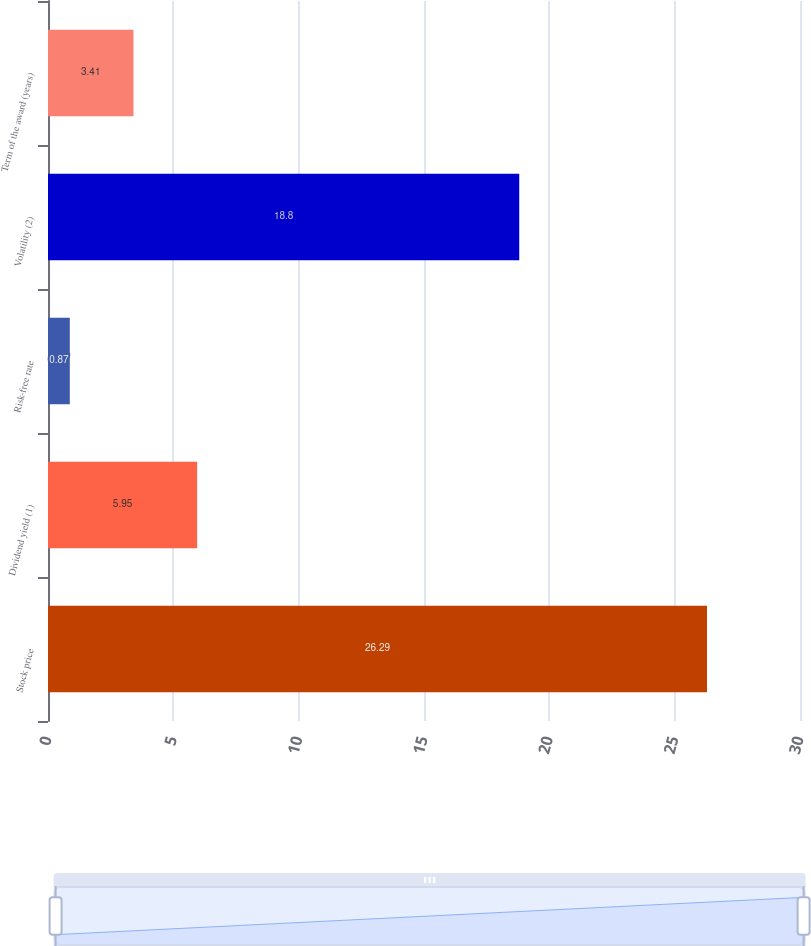Convert chart to OTSL. <chart><loc_0><loc_0><loc_500><loc_500><bar_chart><fcel>Stock price<fcel>Dividend yield (1)<fcel>Risk-free rate<fcel>Volatility (2)<fcel>Term of the award (years)<nl><fcel>26.29<fcel>5.95<fcel>0.87<fcel>18.8<fcel>3.41<nl></chart> 